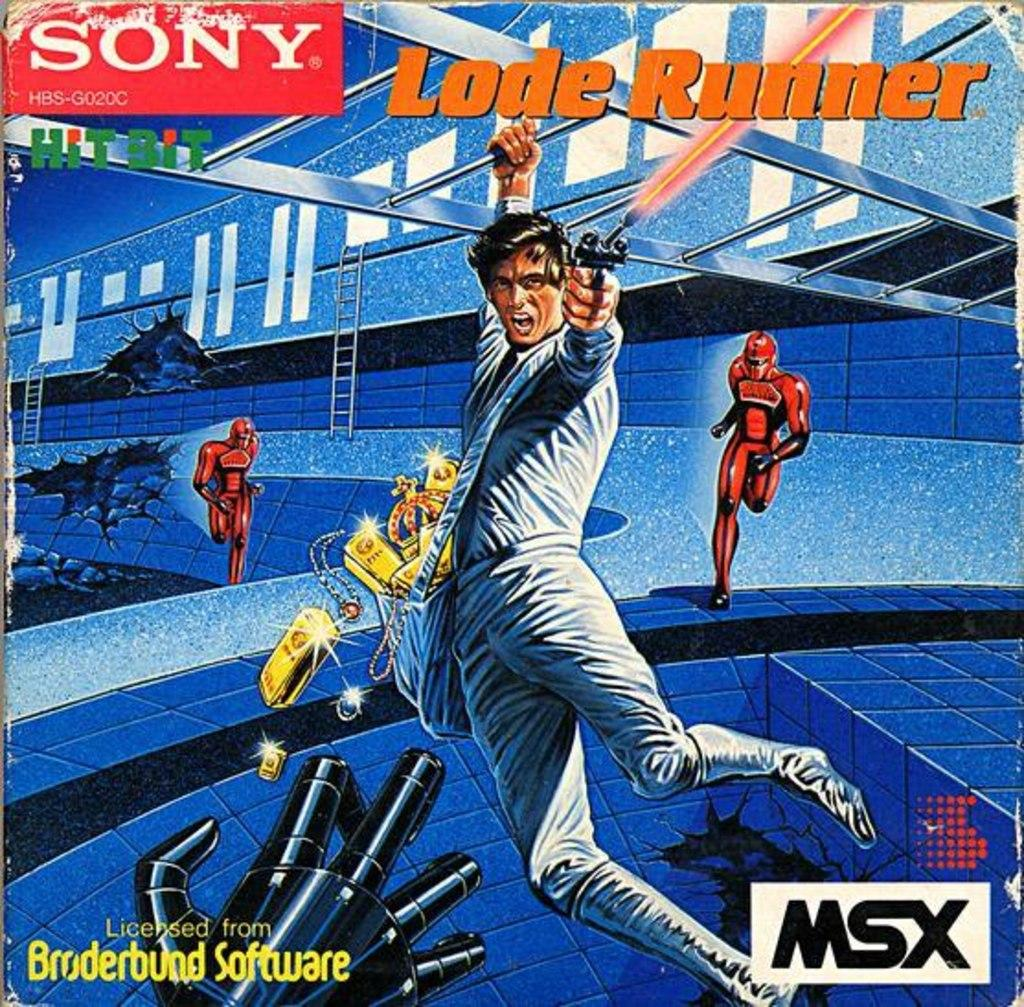What is the main object in the image? There is a poster in the image. What type of images are on the poster? The poster contains cartoon images of persons. Is there any text on the poster? Yes, there is text on the poster. How many buckets are visible in the image? There are no buckets present in the image. What is the amount of ground shown in the image? The image does not show any ground; it only features a poster. 